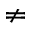<formula> <loc_0><loc_0><loc_500><loc_500>\neq</formula> 